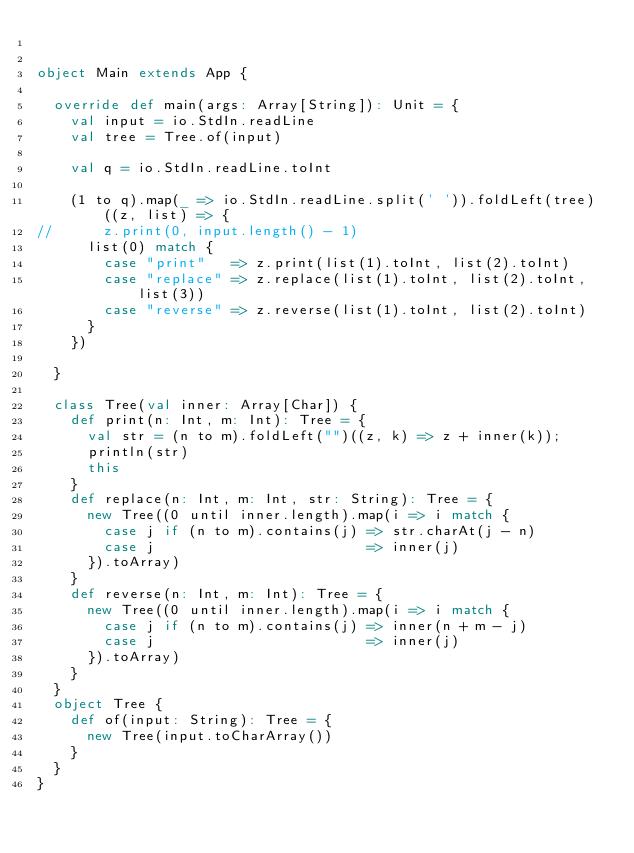<code> <loc_0><loc_0><loc_500><loc_500><_Scala_>

object Main extends App {

  override def main(args: Array[String]): Unit = {
    val input = io.StdIn.readLine
    val tree = Tree.of(input)

    val q = io.StdIn.readLine.toInt

    (1 to q).map(_ => io.StdIn.readLine.split(' ')).foldLeft(tree)((z, list) => {
//      z.print(0, input.length() - 1)
      list(0) match {
        case "print"   => z.print(list(1).toInt, list(2).toInt)
        case "replace" => z.replace(list(1).toInt, list(2).toInt, list(3))
        case "reverse" => z.reverse(list(1).toInt, list(2).toInt)
      }
    })

  }

  class Tree(val inner: Array[Char]) {
    def print(n: Int, m: Int): Tree = {
      val str = (n to m).foldLeft("")((z, k) => z + inner(k));
      println(str)
      this
    }
    def replace(n: Int, m: Int, str: String): Tree = {
      new Tree((0 until inner.length).map(i => i match {
        case j if (n to m).contains(j) => str.charAt(j - n)
        case j                         => inner(j)
      }).toArray)
    }
    def reverse(n: Int, m: Int): Tree = {
      new Tree((0 until inner.length).map(i => i match {
        case j if (n to m).contains(j) => inner(n + m - j)
        case j                         => inner(j)
      }).toArray)
    }
  }
  object Tree {
    def of(input: String): Tree = {
      new Tree(input.toCharArray())
    }
  }
}</code> 